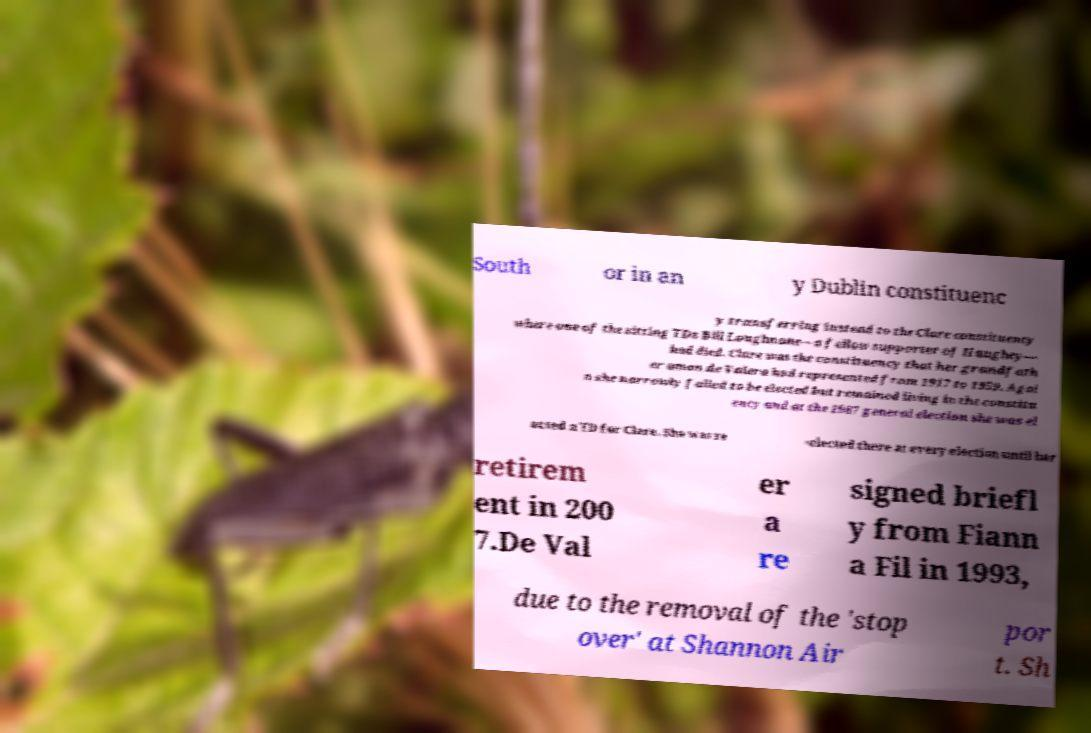Could you assist in decoding the text presented in this image and type it out clearly? South or in an y Dublin constituenc y transferring instead to the Clare constituency where one of the sitting TDs Bill Loughnane—a fellow supporter of Haughey— had died. Clare was the constituency that her grandfath er amon de Valera had represented from 1917 to 1959. Agai n she narrowly failed to be elected but remained living in the constitu ency and at the 1987 general election she was el ected a TD for Clare. She was re -elected there at every election until her retirem ent in 200 7.De Val er a re signed briefl y from Fiann a Fil in 1993, due to the removal of the 'stop over' at Shannon Air por t. Sh 